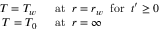Convert formula to latex. <formula><loc_0><loc_0><loc_500><loc_500>\begin{array} { r l } { T = T _ { w } \, } & a t \, r = r _ { w } \, f o r \, t ^ { \prime } \geq 0 } \\ { T = T _ { 0 } \, } & a t \, r = \infty } \end{array}</formula> 